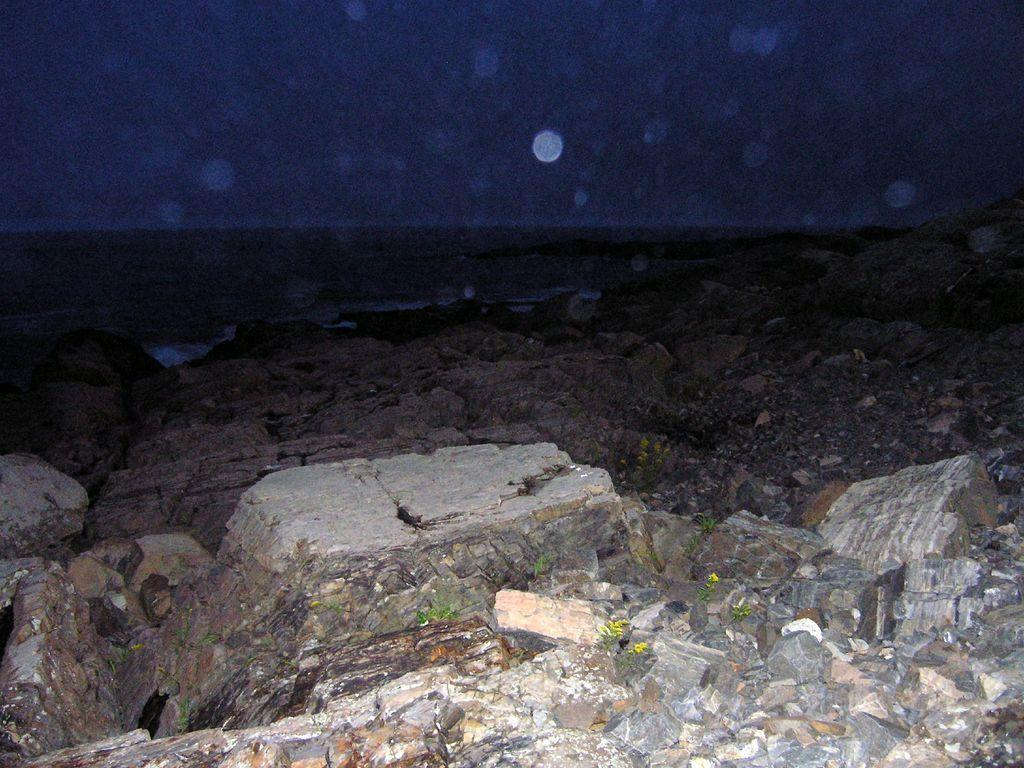What type of natural elements can be seen in the image? There are rocks and plants in the image. What can be seen in the background of the image? The sky is visible in the background of the image. What type of popcorn can be seen growing on the rocks in the image? There is no popcorn present in the image; it is a natural scene with rocks and plants. How does the wrist of the person in the image look like? There is no person present in the image, so it is not possible to describe a wrist. 